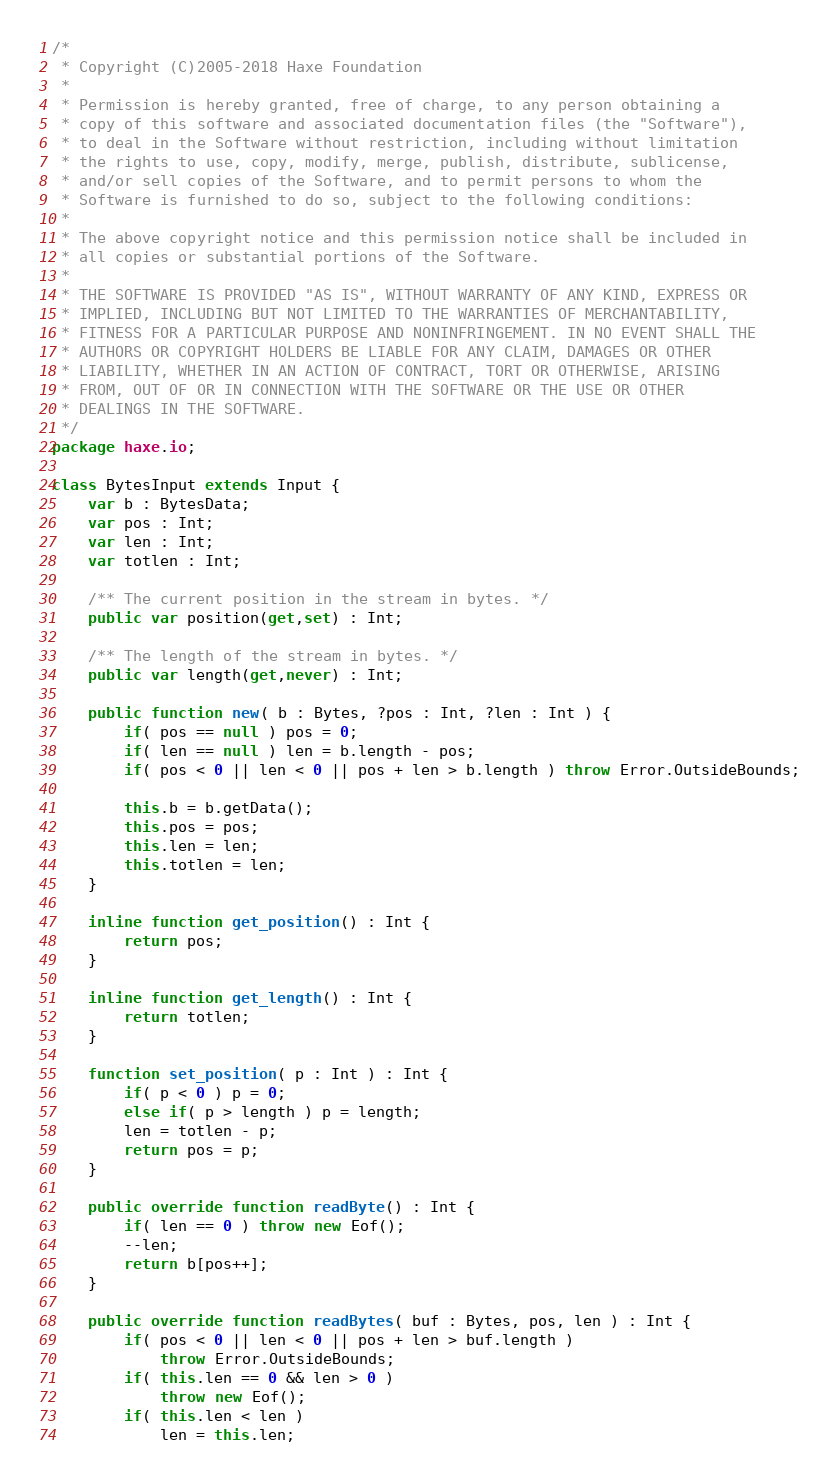<code> <loc_0><loc_0><loc_500><loc_500><_Haxe_>/*
 * Copyright (C)2005-2018 Haxe Foundation
 *
 * Permission is hereby granted, free of charge, to any person obtaining a
 * copy of this software and associated documentation files (the "Software"),
 * to deal in the Software without restriction, including without limitation
 * the rights to use, copy, modify, merge, publish, distribute, sublicense,
 * and/or sell copies of the Software, and to permit persons to whom the
 * Software is furnished to do so, subject to the following conditions:
 *
 * The above copyright notice and this permission notice shall be included in
 * all copies or substantial portions of the Software.
 *
 * THE SOFTWARE IS PROVIDED "AS IS", WITHOUT WARRANTY OF ANY KIND, EXPRESS OR
 * IMPLIED, INCLUDING BUT NOT LIMITED TO THE WARRANTIES OF MERCHANTABILITY,
 * FITNESS FOR A PARTICULAR PURPOSE AND NONINFRINGEMENT. IN NO EVENT SHALL THE
 * AUTHORS OR COPYRIGHT HOLDERS BE LIABLE FOR ANY CLAIM, DAMAGES OR OTHER
 * LIABILITY, WHETHER IN AN ACTION OF CONTRACT, TORT OR OTHERWISE, ARISING
 * FROM, OUT OF OR IN CONNECTION WITH THE SOFTWARE OR THE USE OR OTHER
 * DEALINGS IN THE SOFTWARE.
 */
package haxe.io;

class BytesInput extends Input {
	var b : BytesData;
	var pos : Int;
	var len : Int;
	var totlen : Int;

	/** The current position in the stream in bytes. */
	public var position(get,set) : Int;

	/** The length of the stream in bytes. */
	public var length(get,never) : Int;

	public function new( b : Bytes, ?pos : Int, ?len : Int ) {
		if( pos == null ) pos = 0;
		if( len == null ) len = b.length - pos;
		if( pos < 0 || len < 0 || pos + len > b.length ) throw Error.OutsideBounds;

		this.b = b.getData();
		this.pos = pos;
		this.len = len;
		this.totlen = len;
	}

	inline function get_position() : Int {
		return pos;
	}

	inline function get_length() : Int {
		return totlen;
	}

	function set_position( p : Int ) : Int {
		if( p < 0 ) p = 0;
		else if( p > length ) p = length;
		len = totlen - p;
		return pos = p;
	}

	public override function readByte() : Int {
		if( len == 0 ) throw new Eof();
		--len;
		return b[pos++];
	}

	public override function readBytes( buf : Bytes, pos, len ) : Int {
		if( pos < 0 || len < 0 || pos + len > buf.length )
			throw Error.OutsideBounds;
		if( this.len == 0 && len > 0 )
			throw new Eof();
		if( this.len < len )
			len = this.len;</code> 